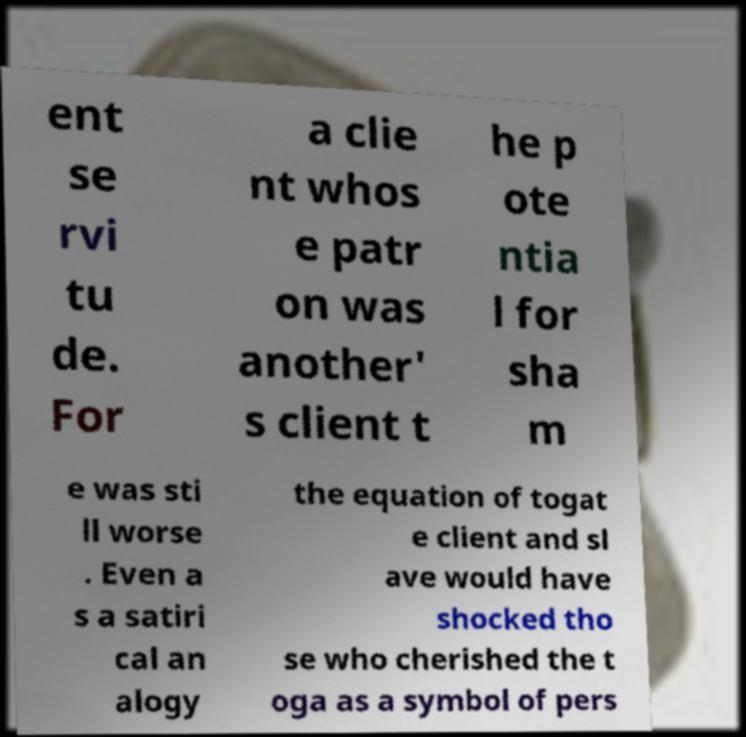Please read and relay the text visible in this image. What does it say? ent se rvi tu de. For a clie nt whos e patr on was another' s client t he p ote ntia l for sha m e was sti ll worse . Even a s a satiri cal an alogy the equation of togat e client and sl ave would have shocked tho se who cherished the t oga as a symbol of pers 